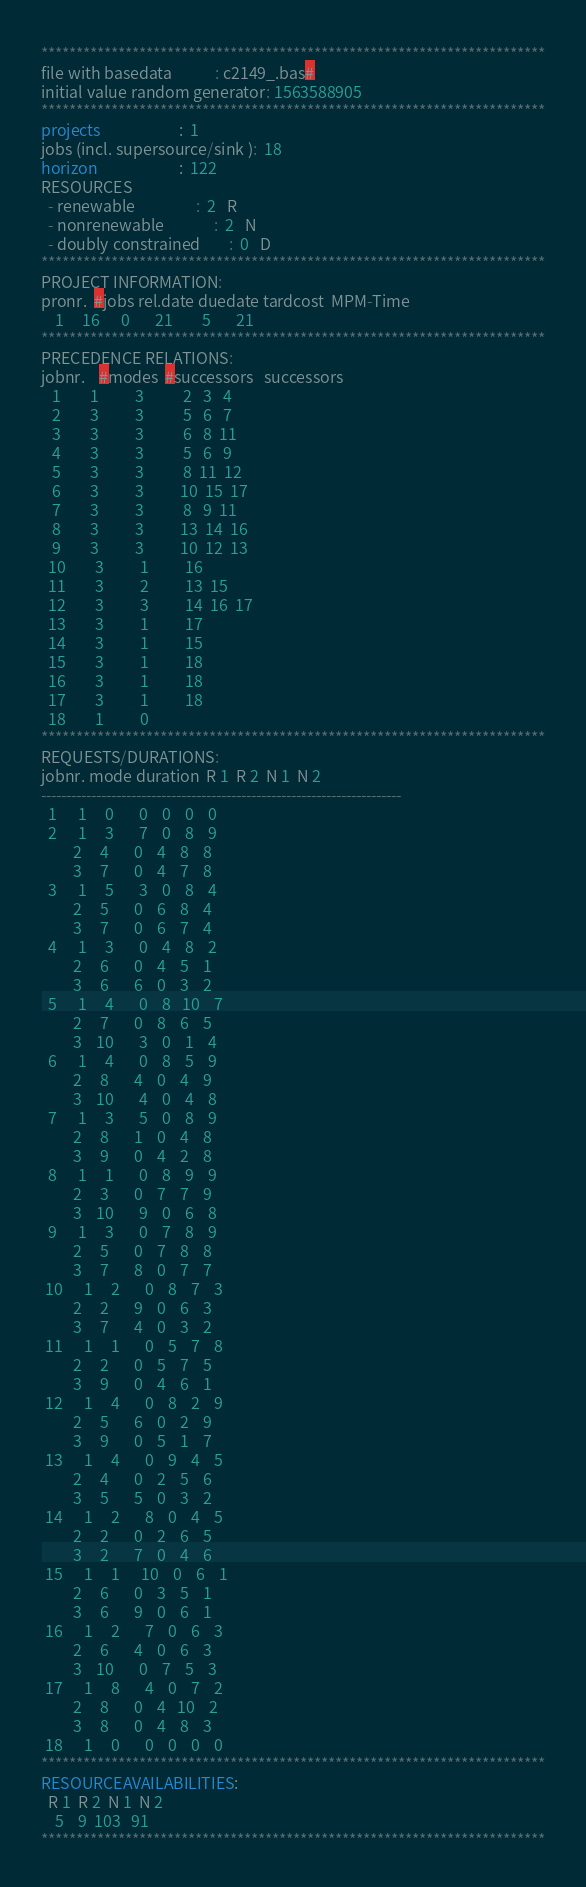Convert code to text. <code><loc_0><loc_0><loc_500><loc_500><_ObjectiveC_>************************************************************************
file with basedata            : c2149_.bas#
initial value random generator: 1563588905
************************************************************************
projects                      :  1
jobs (incl. supersource/sink ):  18
horizon                       :  122
RESOURCES
  - renewable                 :  2   R
  - nonrenewable              :  2   N
  - doubly constrained        :  0   D
************************************************************************
PROJECT INFORMATION:
pronr.  #jobs rel.date duedate tardcost  MPM-Time
    1     16      0       21        5       21
************************************************************************
PRECEDENCE RELATIONS:
jobnr.    #modes  #successors   successors
   1        1          3           2   3   4
   2        3          3           5   6   7
   3        3          3           6   8  11
   4        3          3           5   6   9
   5        3          3           8  11  12
   6        3          3          10  15  17
   7        3          3           8   9  11
   8        3          3          13  14  16
   9        3          3          10  12  13
  10        3          1          16
  11        3          2          13  15
  12        3          3          14  16  17
  13        3          1          17
  14        3          1          15
  15        3          1          18
  16        3          1          18
  17        3          1          18
  18        1          0        
************************************************************************
REQUESTS/DURATIONS:
jobnr. mode duration  R 1  R 2  N 1  N 2
------------------------------------------------------------------------
  1      1     0       0    0    0    0
  2      1     3       7    0    8    9
         2     4       0    4    8    8
         3     7       0    4    7    8
  3      1     5       3    0    8    4
         2     5       0    6    8    4
         3     7       0    6    7    4
  4      1     3       0    4    8    2
         2     6       0    4    5    1
         3     6       6    0    3    2
  5      1     4       0    8   10    7
         2     7       0    8    6    5
         3    10       3    0    1    4
  6      1     4       0    8    5    9
         2     8       4    0    4    9
         3    10       4    0    4    8
  7      1     3       5    0    8    9
         2     8       1    0    4    8
         3     9       0    4    2    8
  8      1     1       0    8    9    9
         2     3       0    7    7    9
         3    10       9    0    6    8
  9      1     3       0    7    8    9
         2     5       0    7    8    8
         3     7       8    0    7    7
 10      1     2       0    8    7    3
         2     2       9    0    6    3
         3     7       4    0    3    2
 11      1     1       0    5    7    8
         2     2       0    5    7    5
         3     9       0    4    6    1
 12      1     4       0    8    2    9
         2     5       6    0    2    9
         3     9       0    5    1    7
 13      1     4       0    9    4    5
         2     4       0    2    5    6
         3     5       5    0    3    2
 14      1     2       8    0    4    5
         2     2       0    2    6    5
         3     2       7    0    4    6
 15      1     1      10    0    6    1
         2     6       0    3    5    1
         3     6       9    0    6    1
 16      1     2       7    0    6    3
         2     6       4    0    6    3
         3    10       0    7    5    3
 17      1     8       4    0    7    2
         2     8       0    4   10    2
         3     8       0    4    8    3
 18      1     0       0    0    0    0
************************************************************************
RESOURCEAVAILABILITIES:
  R 1  R 2  N 1  N 2
    5    9  103   91
************************************************************************
</code> 